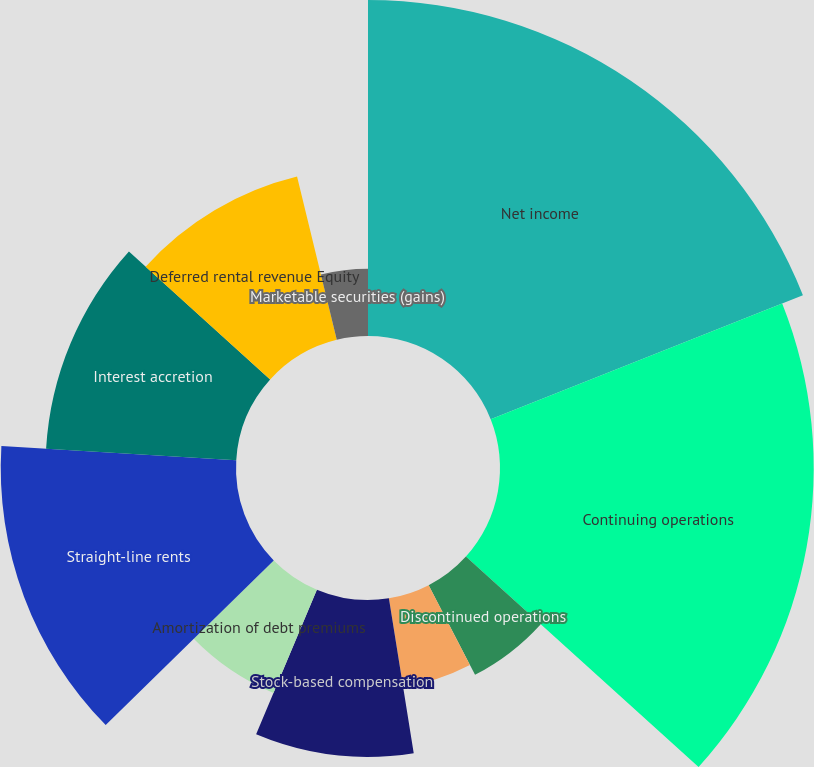Convert chart to OTSL. <chart><loc_0><loc_0><loc_500><loc_500><pie_chart><fcel>Net income<fcel>Continuing operations<fcel>Discontinued operations<fcel>Amortization of above and<fcel>Stock-based compensation<fcel>Amortization of debt premiums<fcel>Straight-line rents<fcel>Interest accretion<fcel>Deferred rental revenue Equity<fcel>Marketable securities (gains)<nl><fcel>18.98%<fcel>17.72%<fcel>5.7%<fcel>5.07%<fcel>8.86%<fcel>6.33%<fcel>13.29%<fcel>10.76%<fcel>9.49%<fcel>3.8%<nl></chart> 